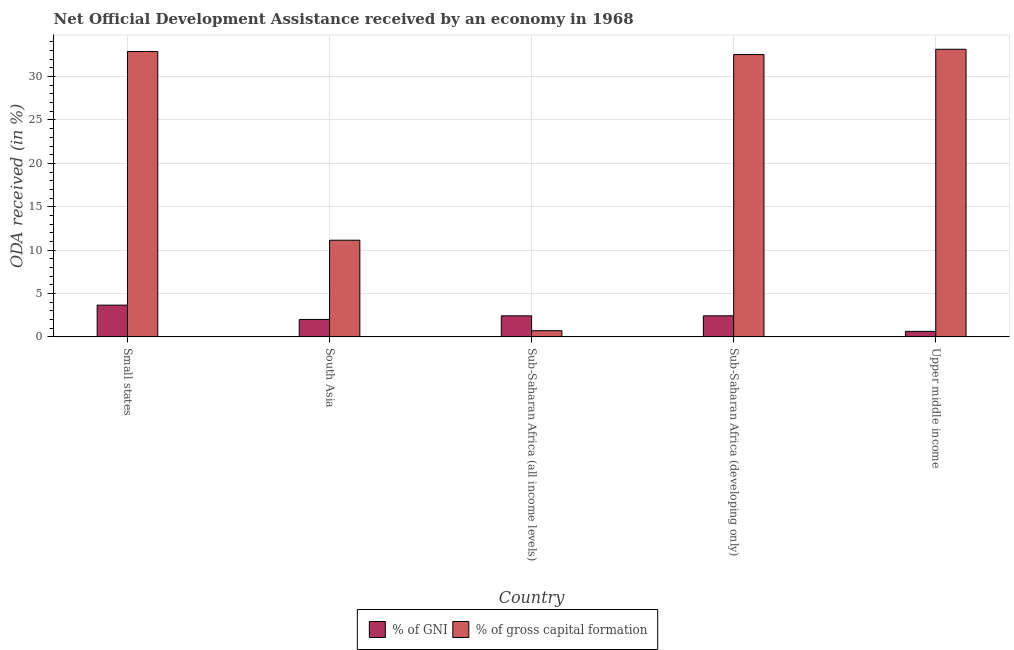How many groups of bars are there?
Offer a terse response. 5. Are the number of bars on each tick of the X-axis equal?
Keep it short and to the point. Yes. How many bars are there on the 1st tick from the right?
Give a very brief answer. 2. What is the oda received as percentage of gross capital formation in Small states?
Your answer should be compact. 32.9. Across all countries, what is the maximum oda received as percentage of gross capital formation?
Offer a terse response. 33.15. Across all countries, what is the minimum oda received as percentage of gni?
Your response must be concise. 0.63. In which country was the oda received as percentage of gni maximum?
Offer a terse response. Small states. In which country was the oda received as percentage of gross capital formation minimum?
Offer a very short reply. Sub-Saharan Africa (all income levels). What is the total oda received as percentage of gross capital formation in the graph?
Offer a terse response. 110.44. What is the difference between the oda received as percentage of gross capital formation in Sub-Saharan Africa (all income levels) and that in Sub-Saharan Africa (developing only)?
Ensure brevity in your answer.  -31.83. What is the difference between the oda received as percentage of gni in Upper middle income and the oda received as percentage of gross capital formation in South Asia?
Provide a short and direct response. -10.51. What is the average oda received as percentage of gni per country?
Ensure brevity in your answer.  2.23. What is the difference between the oda received as percentage of gross capital formation and oda received as percentage of gni in Upper middle income?
Give a very brief answer. 32.52. What is the ratio of the oda received as percentage of gross capital formation in Sub-Saharan Africa (all income levels) to that in Upper middle income?
Provide a short and direct response. 0.02. Is the oda received as percentage of gni in Small states less than that in Upper middle income?
Your answer should be very brief. No. What is the difference between the highest and the second highest oda received as percentage of gross capital formation?
Provide a succinct answer. 0.26. What is the difference between the highest and the lowest oda received as percentage of gni?
Make the answer very short. 3.03. What does the 1st bar from the left in Upper middle income represents?
Provide a succinct answer. % of GNI. What does the 1st bar from the right in Upper middle income represents?
Keep it short and to the point. % of gross capital formation. How many countries are there in the graph?
Give a very brief answer. 5. What is the difference between two consecutive major ticks on the Y-axis?
Your response must be concise. 5. Are the values on the major ticks of Y-axis written in scientific E-notation?
Provide a succinct answer. No. Does the graph contain grids?
Offer a terse response. Yes. Where does the legend appear in the graph?
Keep it short and to the point. Bottom center. How many legend labels are there?
Offer a terse response. 2. What is the title of the graph?
Make the answer very short. Net Official Development Assistance received by an economy in 1968. What is the label or title of the X-axis?
Your response must be concise. Country. What is the label or title of the Y-axis?
Ensure brevity in your answer.  ODA received (in %). What is the ODA received (in %) of % of GNI in Small states?
Keep it short and to the point. 3.66. What is the ODA received (in %) in % of gross capital formation in Small states?
Keep it short and to the point. 32.9. What is the ODA received (in %) in % of GNI in South Asia?
Make the answer very short. 2.01. What is the ODA received (in %) of % of gross capital formation in South Asia?
Your answer should be very brief. 11.14. What is the ODA received (in %) in % of GNI in Sub-Saharan Africa (all income levels)?
Provide a short and direct response. 2.42. What is the ODA received (in %) of % of gross capital formation in Sub-Saharan Africa (all income levels)?
Your response must be concise. 0.71. What is the ODA received (in %) in % of GNI in Sub-Saharan Africa (developing only)?
Offer a terse response. 2.43. What is the ODA received (in %) in % of gross capital formation in Sub-Saharan Africa (developing only)?
Your response must be concise. 32.54. What is the ODA received (in %) of % of GNI in Upper middle income?
Provide a short and direct response. 0.63. What is the ODA received (in %) of % of gross capital formation in Upper middle income?
Offer a very short reply. 33.15. Across all countries, what is the maximum ODA received (in %) of % of GNI?
Provide a succinct answer. 3.66. Across all countries, what is the maximum ODA received (in %) of % of gross capital formation?
Your answer should be very brief. 33.15. Across all countries, what is the minimum ODA received (in %) of % of GNI?
Provide a succinct answer. 0.63. Across all countries, what is the minimum ODA received (in %) in % of gross capital formation?
Ensure brevity in your answer.  0.71. What is the total ODA received (in %) of % of GNI in the graph?
Provide a short and direct response. 11.15. What is the total ODA received (in %) of % of gross capital formation in the graph?
Ensure brevity in your answer.  110.44. What is the difference between the ODA received (in %) in % of GNI in Small states and that in South Asia?
Your response must be concise. 1.65. What is the difference between the ODA received (in %) of % of gross capital formation in Small states and that in South Asia?
Your answer should be compact. 21.75. What is the difference between the ODA received (in %) in % of GNI in Small states and that in Sub-Saharan Africa (all income levels)?
Provide a short and direct response. 1.23. What is the difference between the ODA received (in %) in % of gross capital formation in Small states and that in Sub-Saharan Africa (all income levels)?
Ensure brevity in your answer.  32.18. What is the difference between the ODA received (in %) in % of GNI in Small states and that in Sub-Saharan Africa (developing only)?
Your answer should be compact. 1.23. What is the difference between the ODA received (in %) of % of gross capital formation in Small states and that in Sub-Saharan Africa (developing only)?
Your response must be concise. 0.36. What is the difference between the ODA received (in %) of % of GNI in Small states and that in Upper middle income?
Provide a succinct answer. 3.03. What is the difference between the ODA received (in %) of % of gross capital formation in Small states and that in Upper middle income?
Make the answer very short. -0.26. What is the difference between the ODA received (in %) of % of GNI in South Asia and that in Sub-Saharan Africa (all income levels)?
Ensure brevity in your answer.  -0.41. What is the difference between the ODA received (in %) in % of gross capital formation in South Asia and that in Sub-Saharan Africa (all income levels)?
Your answer should be very brief. 10.43. What is the difference between the ODA received (in %) of % of GNI in South Asia and that in Sub-Saharan Africa (developing only)?
Ensure brevity in your answer.  -0.42. What is the difference between the ODA received (in %) of % of gross capital formation in South Asia and that in Sub-Saharan Africa (developing only)?
Ensure brevity in your answer.  -21.4. What is the difference between the ODA received (in %) in % of GNI in South Asia and that in Upper middle income?
Offer a very short reply. 1.38. What is the difference between the ODA received (in %) of % of gross capital formation in South Asia and that in Upper middle income?
Your response must be concise. -22.01. What is the difference between the ODA received (in %) in % of GNI in Sub-Saharan Africa (all income levels) and that in Sub-Saharan Africa (developing only)?
Provide a succinct answer. -0. What is the difference between the ODA received (in %) of % of gross capital formation in Sub-Saharan Africa (all income levels) and that in Sub-Saharan Africa (developing only)?
Ensure brevity in your answer.  -31.83. What is the difference between the ODA received (in %) in % of GNI in Sub-Saharan Africa (all income levels) and that in Upper middle income?
Offer a very short reply. 1.79. What is the difference between the ODA received (in %) in % of gross capital formation in Sub-Saharan Africa (all income levels) and that in Upper middle income?
Give a very brief answer. -32.44. What is the difference between the ODA received (in %) in % of GNI in Sub-Saharan Africa (developing only) and that in Upper middle income?
Your answer should be very brief. 1.79. What is the difference between the ODA received (in %) in % of gross capital formation in Sub-Saharan Africa (developing only) and that in Upper middle income?
Your response must be concise. -0.61. What is the difference between the ODA received (in %) of % of GNI in Small states and the ODA received (in %) of % of gross capital formation in South Asia?
Give a very brief answer. -7.48. What is the difference between the ODA received (in %) of % of GNI in Small states and the ODA received (in %) of % of gross capital formation in Sub-Saharan Africa (all income levels)?
Ensure brevity in your answer.  2.95. What is the difference between the ODA received (in %) of % of GNI in Small states and the ODA received (in %) of % of gross capital formation in Sub-Saharan Africa (developing only)?
Your answer should be compact. -28.88. What is the difference between the ODA received (in %) of % of GNI in Small states and the ODA received (in %) of % of gross capital formation in Upper middle income?
Your response must be concise. -29.49. What is the difference between the ODA received (in %) in % of GNI in South Asia and the ODA received (in %) in % of gross capital formation in Sub-Saharan Africa (all income levels)?
Offer a very short reply. 1.3. What is the difference between the ODA received (in %) of % of GNI in South Asia and the ODA received (in %) of % of gross capital formation in Sub-Saharan Africa (developing only)?
Ensure brevity in your answer.  -30.53. What is the difference between the ODA received (in %) of % of GNI in South Asia and the ODA received (in %) of % of gross capital formation in Upper middle income?
Offer a terse response. -31.14. What is the difference between the ODA received (in %) of % of GNI in Sub-Saharan Africa (all income levels) and the ODA received (in %) of % of gross capital formation in Sub-Saharan Africa (developing only)?
Keep it short and to the point. -30.12. What is the difference between the ODA received (in %) of % of GNI in Sub-Saharan Africa (all income levels) and the ODA received (in %) of % of gross capital formation in Upper middle income?
Your answer should be compact. -30.73. What is the difference between the ODA received (in %) of % of GNI in Sub-Saharan Africa (developing only) and the ODA received (in %) of % of gross capital formation in Upper middle income?
Provide a short and direct response. -30.73. What is the average ODA received (in %) of % of GNI per country?
Provide a succinct answer. 2.23. What is the average ODA received (in %) of % of gross capital formation per country?
Your response must be concise. 22.09. What is the difference between the ODA received (in %) of % of GNI and ODA received (in %) of % of gross capital formation in Small states?
Your answer should be compact. -29.24. What is the difference between the ODA received (in %) in % of GNI and ODA received (in %) in % of gross capital formation in South Asia?
Your response must be concise. -9.13. What is the difference between the ODA received (in %) in % of GNI and ODA received (in %) in % of gross capital formation in Sub-Saharan Africa (all income levels)?
Keep it short and to the point. 1.71. What is the difference between the ODA received (in %) in % of GNI and ODA received (in %) in % of gross capital formation in Sub-Saharan Africa (developing only)?
Offer a terse response. -30.11. What is the difference between the ODA received (in %) of % of GNI and ODA received (in %) of % of gross capital formation in Upper middle income?
Offer a very short reply. -32.52. What is the ratio of the ODA received (in %) in % of GNI in Small states to that in South Asia?
Your answer should be very brief. 1.82. What is the ratio of the ODA received (in %) in % of gross capital formation in Small states to that in South Asia?
Your answer should be compact. 2.95. What is the ratio of the ODA received (in %) of % of GNI in Small states to that in Sub-Saharan Africa (all income levels)?
Make the answer very short. 1.51. What is the ratio of the ODA received (in %) in % of gross capital formation in Small states to that in Sub-Saharan Africa (all income levels)?
Make the answer very short. 46.32. What is the ratio of the ODA received (in %) in % of GNI in Small states to that in Sub-Saharan Africa (developing only)?
Ensure brevity in your answer.  1.51. What is the ratio of the ODA received (in %) in % of gross capital formation in Small states to that in Sub-Saharan Africa (developing only)?
Provide a short and direct response. 1.01. What is the ratio of the ODA received (in %) in % of GNI in Small states to that in Upper middle income?
Provide a short and direct response. 5.78. What is the ratio of the ODA received (in %) in % of gross capital formation in Small states to that in Upper middle income?
Offer a terse response. 0.99. What is the ratio of the ODA received (in %) of % of GNI in South Asia to that in Sub-Saharan Africa (all income levels)?
Your answer should be very brief. 0.83. What is the ratio of the ODA received (in %) of % of gross capital formation in South Asia to that in Sub-Saharan Africa (all income levels)?
Ensure brevity in your answer.  15.69. What is the ratio of the ODA received (in %) in % of GNI in South Asia to that in Sub-Saharan Africa (developing only)?
Your answer should be very brief. 0.83. What is the ratio of the ODA received (in %) in % of gross capital formation in South Asia to that in Sub-Saharan Africa (developing only)?
Ensure brevity in your answer.  0.34. What is the ratio of the ODA received (in %) in % of GNI in South Asia to that in Upper middle income?
Your answer should be very brief. 3.18. What is the ratio of the ODA received (in %) in % of gross capital formation in South Asia to that in Upper middle income?
Keep it short and to the point. 0.34. What is the ratio of the ODA received (in %) of % of GNI in Sub-Saharan Africa (all income levels) to that in Sub-Saharan Africa (developing only)?
Provide a succinct answer. 1. What is the ratio of the ODA received (in %) in % of gross capital formation in Sub-Saharan Africa (all income levels) to that in Sub-Saharan Africa (developing only)?
Keep it short and to the point. 0.02. What is the ratio of the ODA received (in %) of % of GNI in Sub-Saharan Africa (all income levels) to that in Upper middle income?
Provide a short and direct response. 3.83. What is the ratio of the ODA received (in %) of % of gross capital formation in Sub-Saharan Africa (all income levels) to that in Upper middle income?
Ensure brevity in your answer.  0.02. What is the ratio of the ODA received (in %) in % of GNI in Sub-Saharan Africa (developing only) to that in Upper middle income?
Give a very brief answer. 3.84. What is the ratio of the ODA received (in %) of % of gross capital formation in Sub-Saharan Africa (developing only) to that in Upper middle income?
Offer a terse response. 0.98. What is the difference between the highest and the second highest ODA received (in %) of % of GNI?
Give a very brief answer. 1.23. What is the difference between the highest and the second highest ODA received (in %) in % of gross capital formation?
Give a very brief answer. 0.26. What is the difference between the highest and the lowest ODA received (in %) of % of GNI?
Keep it short and to the point. 3.03. What is the difference between the highest and the lowest ODA received (in %) in % of gross capital formation?
Give a very brief answer. 32.44. 